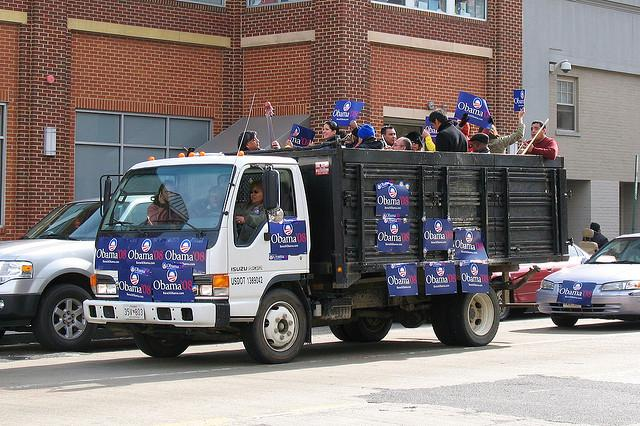Who did they want to be Vice President?

Choices:
A) pence
B) palin
C) clinton
D) biden biden 